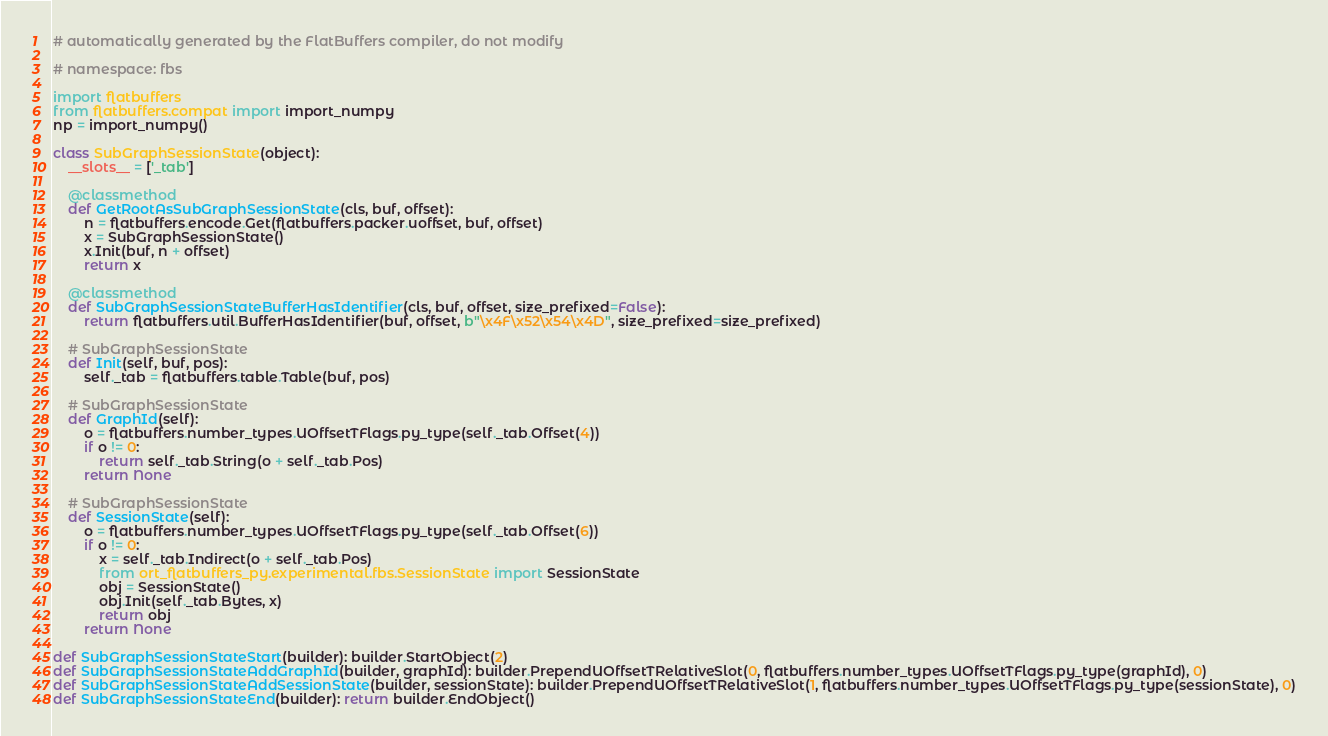<code> <loc_0><loc_0><loc_500><loc_500><_Python_># automatically generated by the FlatBuffers compiler, do not modify

# namespace: fbs

import flatbuffers
from flatbuffers.compat import import_numpy
np = import_numpy()

class SubGraphSessionState(object):
    __slots__ = ['_tab']

    @classmethod
    def GetRootAsSubGraphSessionState(cls, buf, offset):
        n = flatbuffers.encode.Get(flatbuffers.packer.uoffset, buf, offset)
        x = SubGraphSessionState()
        x.Init(buf, n + offset)
        return x

    @classmethod
    def SubGraphSessionStateBufferHasIdentifier(cls, buf, offset, size_prefixed=False):
        return flatbuffers.util.BufferHasIdentifier(buf, offset, b"\x4F\x52\x54\x4D", size_prefixed=size_prefixed)

    # SubGraphSessionState
    def Init(self, buf, pos):
        self._tab = flatbuffers.table.Table(buf, pos)

    # SubGraphSessionState
    def GraphId(self):
        o = flatbuffers.number_types.UOffsetTFlags.py_type(self._tab.Offset(4))
        if o != 0:
            return self._tab.String(o + self._tab.Pos)
        return None

    # SubGraphSessionState
    def SessionState(self):
        o = flatbuffers.number_types.UOffsetTFlags.py_type(self._tab.Offset(6))
        if o != 0:
            x = self._tab.Indirect(o + self._tab.Pos)
            from ort_flatbuffers_py.experimental.fbs.SessionState import SessionState
            obj = SessionState()
            obj.Init(self._tab.Bytes, x)
            return obj
        return None

def SubGraphSessionStateStart(builder): builder.StartObject(2)
def SubGraphSessionStateAddGraphId(builder, graphId): builder.PrependUOffsetTRelativeSlot(0, flatbuffers.number_types.UOffsetTFlags.py_type(graphId), 0)
def SubGraphSessionStateAddSessionState(builder, sessionState): builder.PrependUOffsetTRelativeSlot(1, flatbuffers.number_types.UOffsetTFlags.py_type(sessionState), 0)
def SubGraphSessionStateEnd(builder): return builder.EndObject()
</code> 